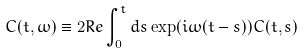<formula> <loc_0><loc_0><loc_500><loc_500>C ( t , \omega ) \equiv 2 { R e } \int _ { 0 } ^ { t } d s \exp ( i \omega ( t - s ) ) C ( t , s ) \,</formula> 